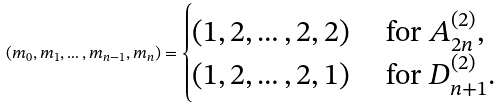Convert formula to latex. <formula><loc_0><loc_0><loc_500><loc_500>( m _ { 0 } , m _ { 1 } , \dots , m _ { n - 1 } , m _ { n } ) = \begin{cases} ( 1 , 2 , \dots , 2 , 2 ) & \text { for } A _ { 2 n } ^ { ( 2 ) } , \\ ( 1 , 2 , \dots , 2 , 1 ) & \text { for } D _ { n + 1 } ^ { ( 2 ) } . \end{cases}</formula> 